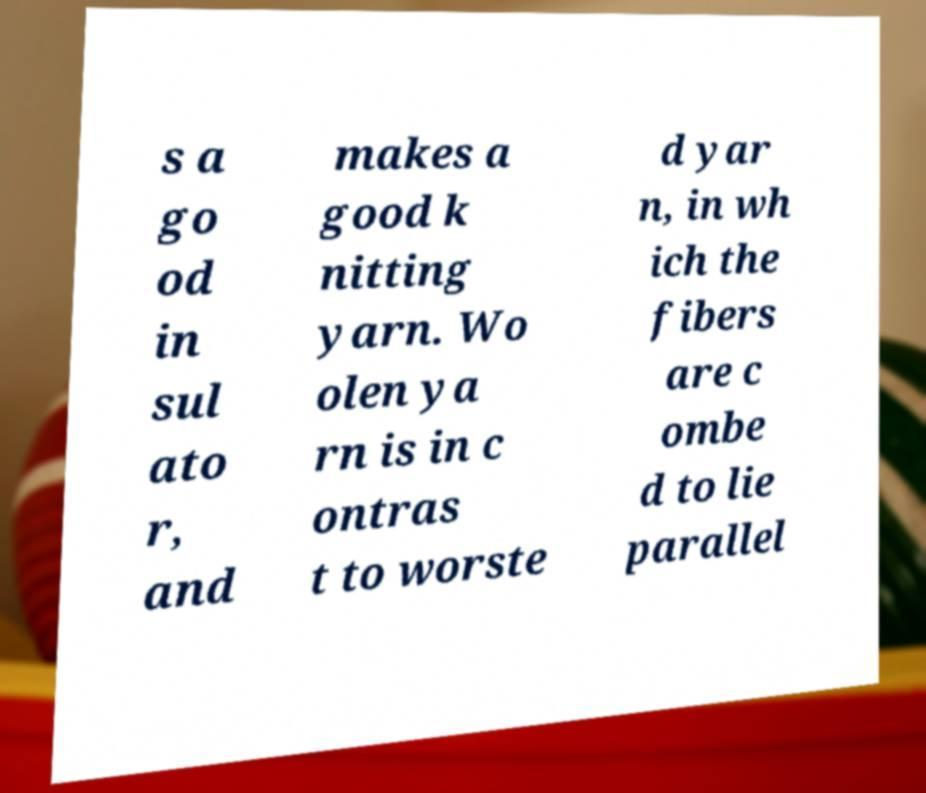Can you read and provide the text displayed in the image?This photo seems to have some interesting text. Can you extract and type it out for me? s a go od in sul ato r, and makes a good k nitting yarn. Wo olen ya rn is in c ontras t to worste d yar n, in wh ich the fibers are c ombe d to lie parallel 